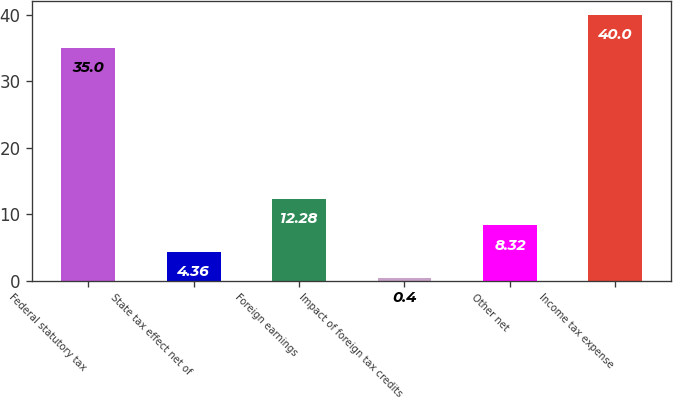<chart> <loc_0><loc_0><loc_500><loc_500><bar_chart><fcel>Federal statutory tax<fcel>State tax effect net of<fcel>Foreign earnings<fcel>Impact of foreign tax credits<fcel>Other net<fcel>Income tax expense<nl><fcel>35<fcel>4.36<fcel>12.28<fcel>0.4<fcel>8.32<fcel>40<nl></chart> 